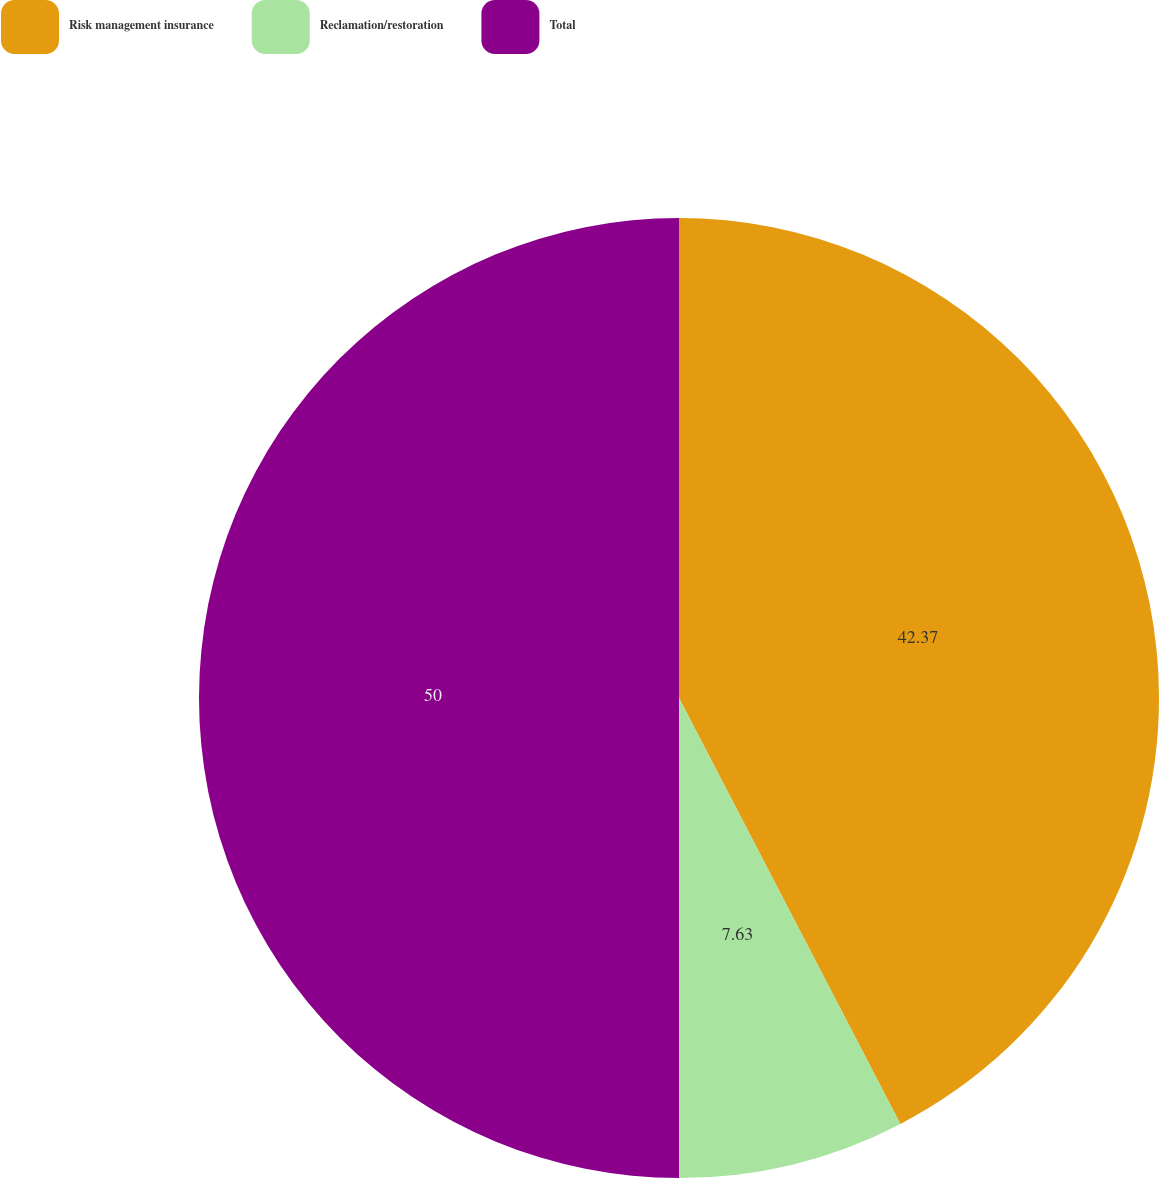Convert chart to OTSL. <chart><loc_0><loc_0><loc_500><loc_500><pie_chart><fcel>Risk management insurance<fcel>Reclamation/restoration<fcel>Total<nl><fcel>42.37%<fcel>7.63%<fcel>50.0%<nl></chart> 